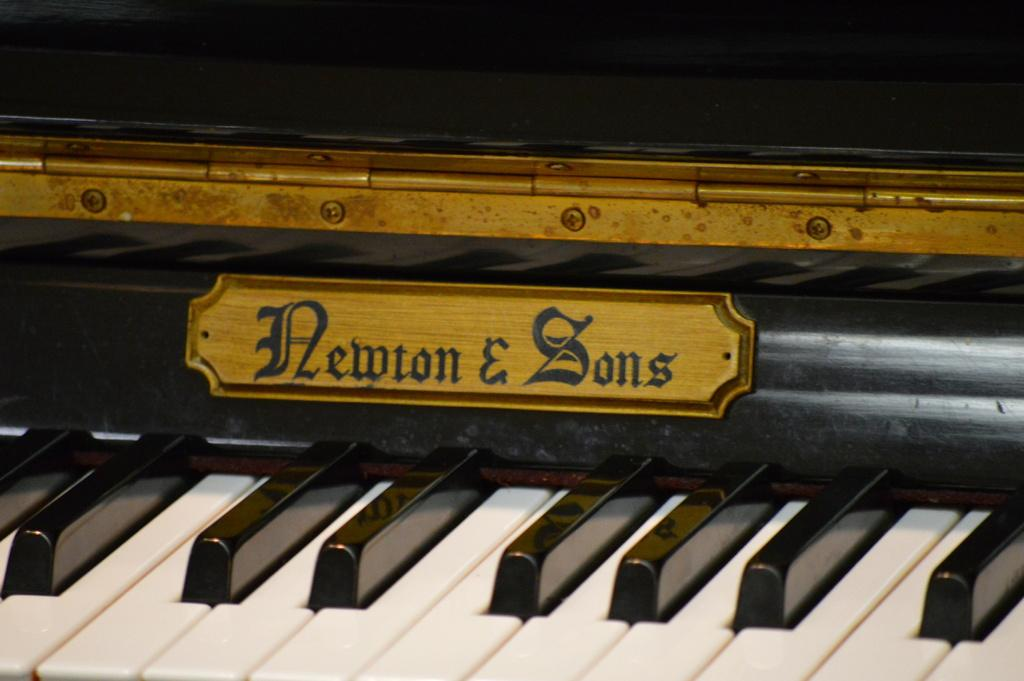What musical instrument is present in the image? There is a piano in the image. How many roses are placed on top of the piano in the image? There are no roses present on top of the piano in the image. Are there any children playing with the piano in the image? There is no indication of children playing with the piano in the image. 